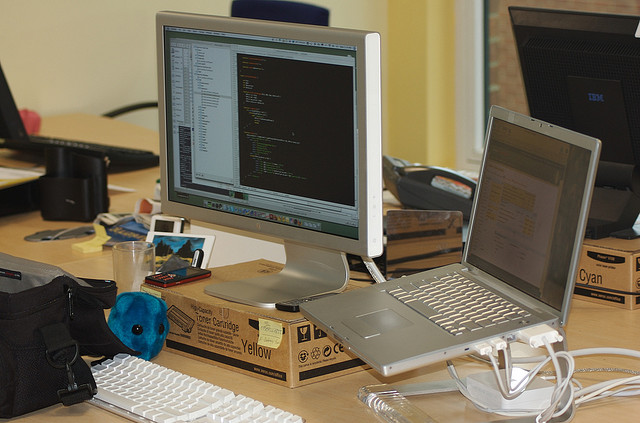Please transcribe the text in this image. Cyan Yellow TONES CABRIDGE 